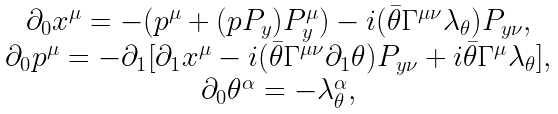<formula> <loc_0><loc_0><loc_500><loc_500>\begin{array} { c } \partial _ { 0 } x ^ { \mu } = - ( p ^ { \mu } + ( p P _ { y } ) P _ { y } ^ { \mu } ) - i ( \bar { \theta } \Gamma ^ { \mu \nu } \lambda _ { \theta } ) P _ { y \nu } , \\ \partial _ { 0 } p ^ { \mu } = - \partial _ { 1 } [ \partial _ { 1 } x ^ { \mu } - i ( \bar { \theta } \Gamma ^ { \mu \nu } \partial _ { 1 } \theta ) P _ { y \nu } + i \bar { \theta } \Gamma ^ { \mu } \lambda _ { \theta } ] , \\ \partial _ { 0 } \theta ^ { \alpha } = - \lambda _ { \theta } ^ { \alpha } , \end{array}</formula> 